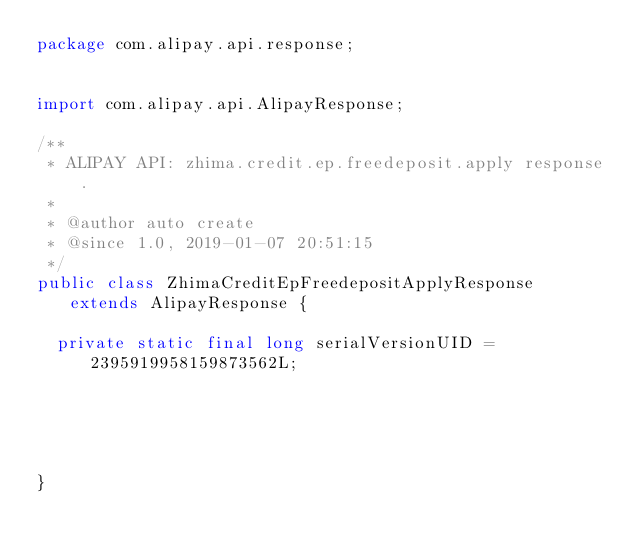Convert code to text. <code><loc_0><loc_0><loc_500><loc_500><_Java_>package com.alipay.api.response;


import com.alipay.api.AlipayResponse;

/**
 * ALIPAY API: zhima.credit.ep.freedeposit.apply response.
 * 
 * @author auto create
 * @since 1.0, 2019-01-07 20:51:15
 */
public class ZhimaCreditEpFreedepositApplyResponse extends AlipayResponse {

	private static final long serialVersionUID = 2395919958159873562L;

	

	

}
</code> 